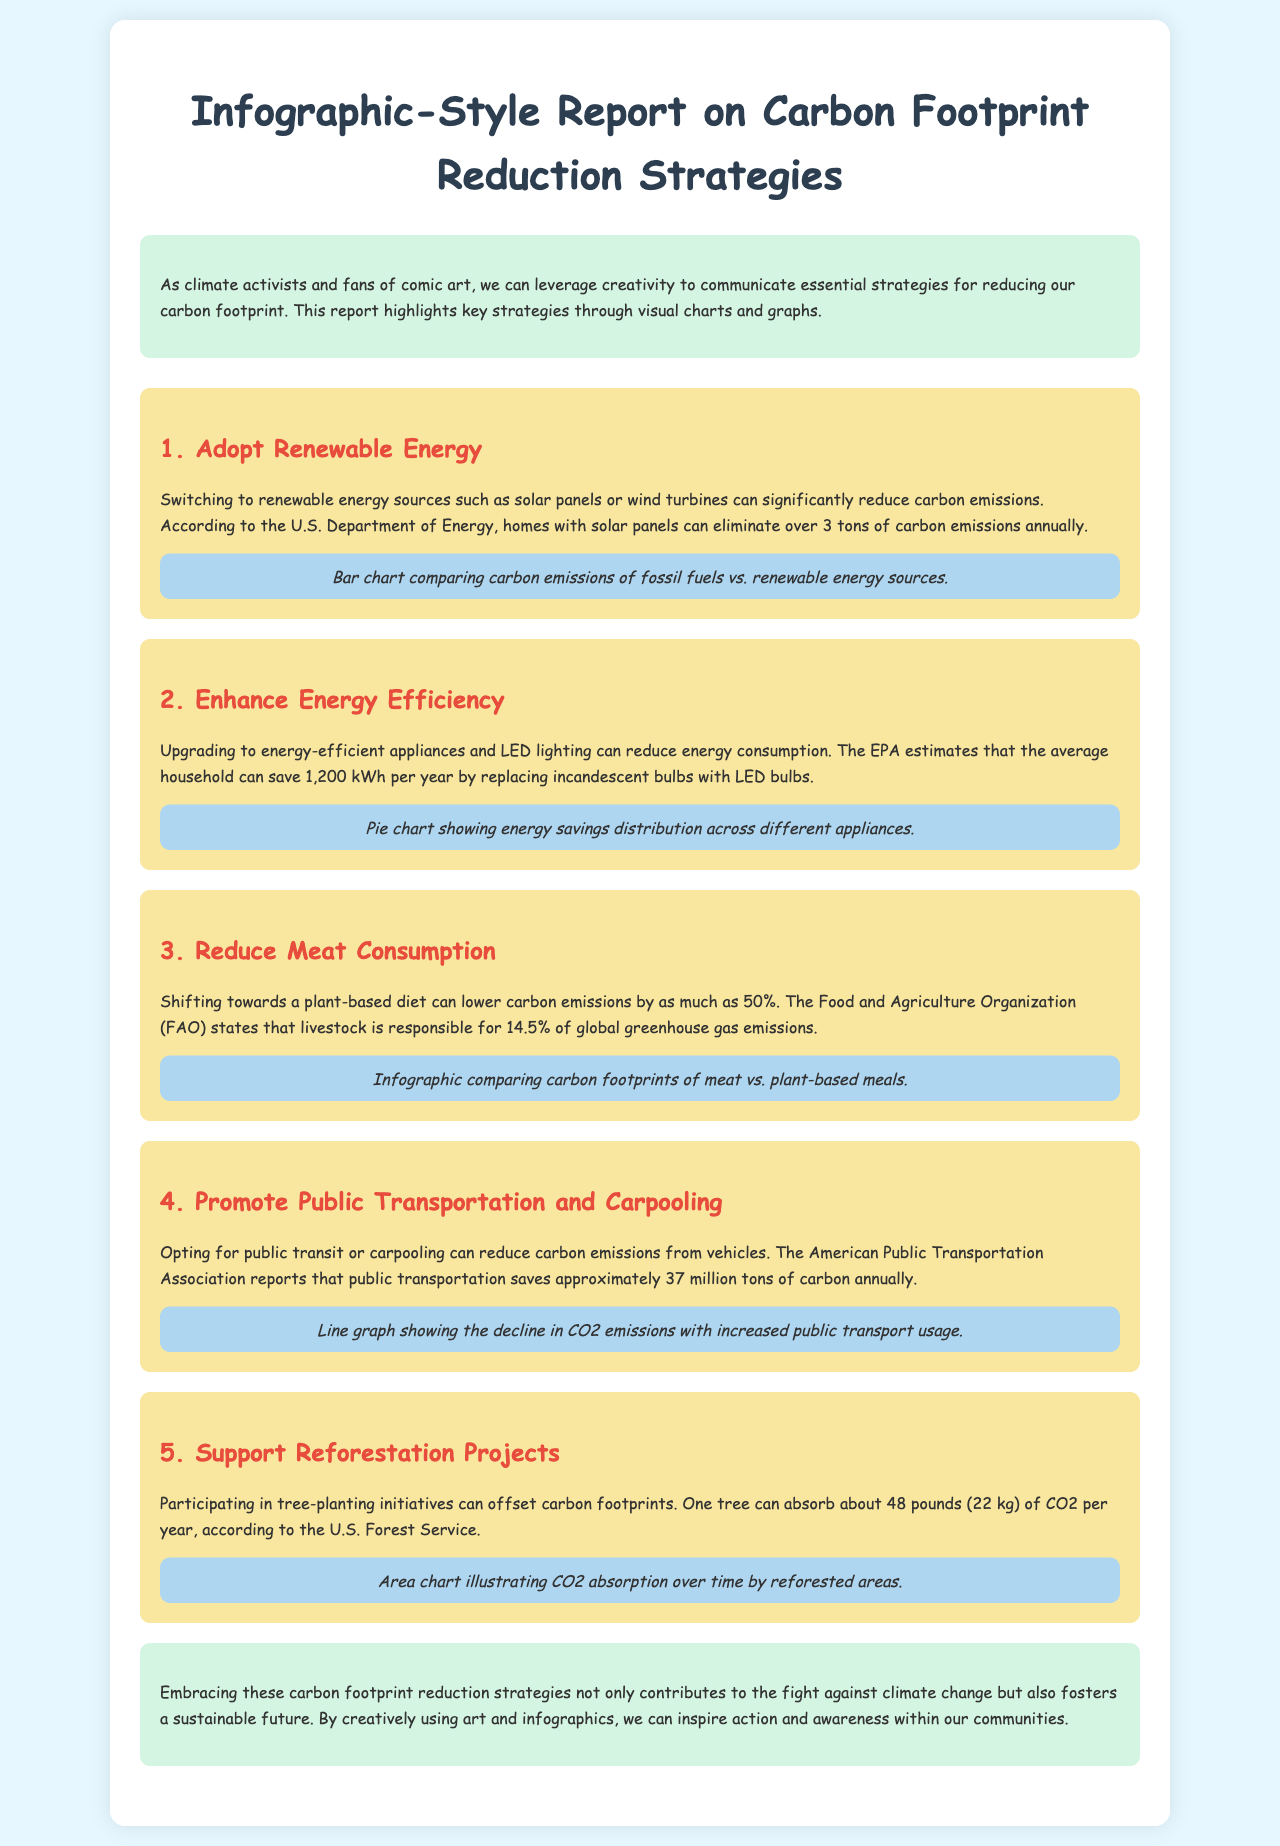What is the introduction about? The introduction discusses leveraging creativity to communicate strategies for reducing carbon footprints through visual charts and graphs.
Answer: Communicating strategies through visuals How many tons of carbon emissions can homes with solar panels eliminate annually? The report states that homes with solar panels can eliminate over 3 tons of carbon emissions annually.
Answer: Over 3 tons What is the estimated energy savings per year by replacing incandescent bulbs with LED bulbs? The EPA estimates that the average household can save 1,200 kWh per year.
Answer: 1,200 kWh What percentage of global greenhouse gas emissions is livestock responsible for, according to the FAO? The Food and Agriculture Organization states that livestock is responsible for 14.5% of global greenhouse gas emissions.
Answer: 14.5% What can one tree absorb per year? According to the U.S. Forest Service, one tree can absorb about 48 pounds of CO2 per year.
Answer: 48 pounds What type of chart compares carbon emissions of fossil fuels vs. renewable energy sources? The report indicates that a bar chart is used to compare carbon emissions of fossil fuels vs. renewable energy sources.
Answer: Bar chart Which strategy suggests reducing vehicle carbon emissions? The strategy that suggests reducing vehicle carbon emissions is promoting public transportation and carpooling.
Answer: Promoting public transportation and carpooling What is the color of the background for the main container of the report? The background color of the main container is white.
Answer: White What is emphasized as a benefit of participating in tree-planting initiatives? The benefit emphasized is that tree-planting can offset carbon footprints.
Answer: Offset carbon footprints 